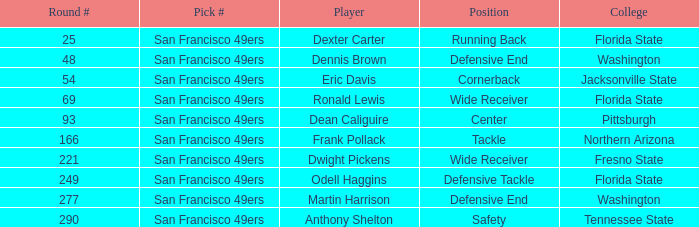What is the college with a circular # that is 290? Tennessee State. 